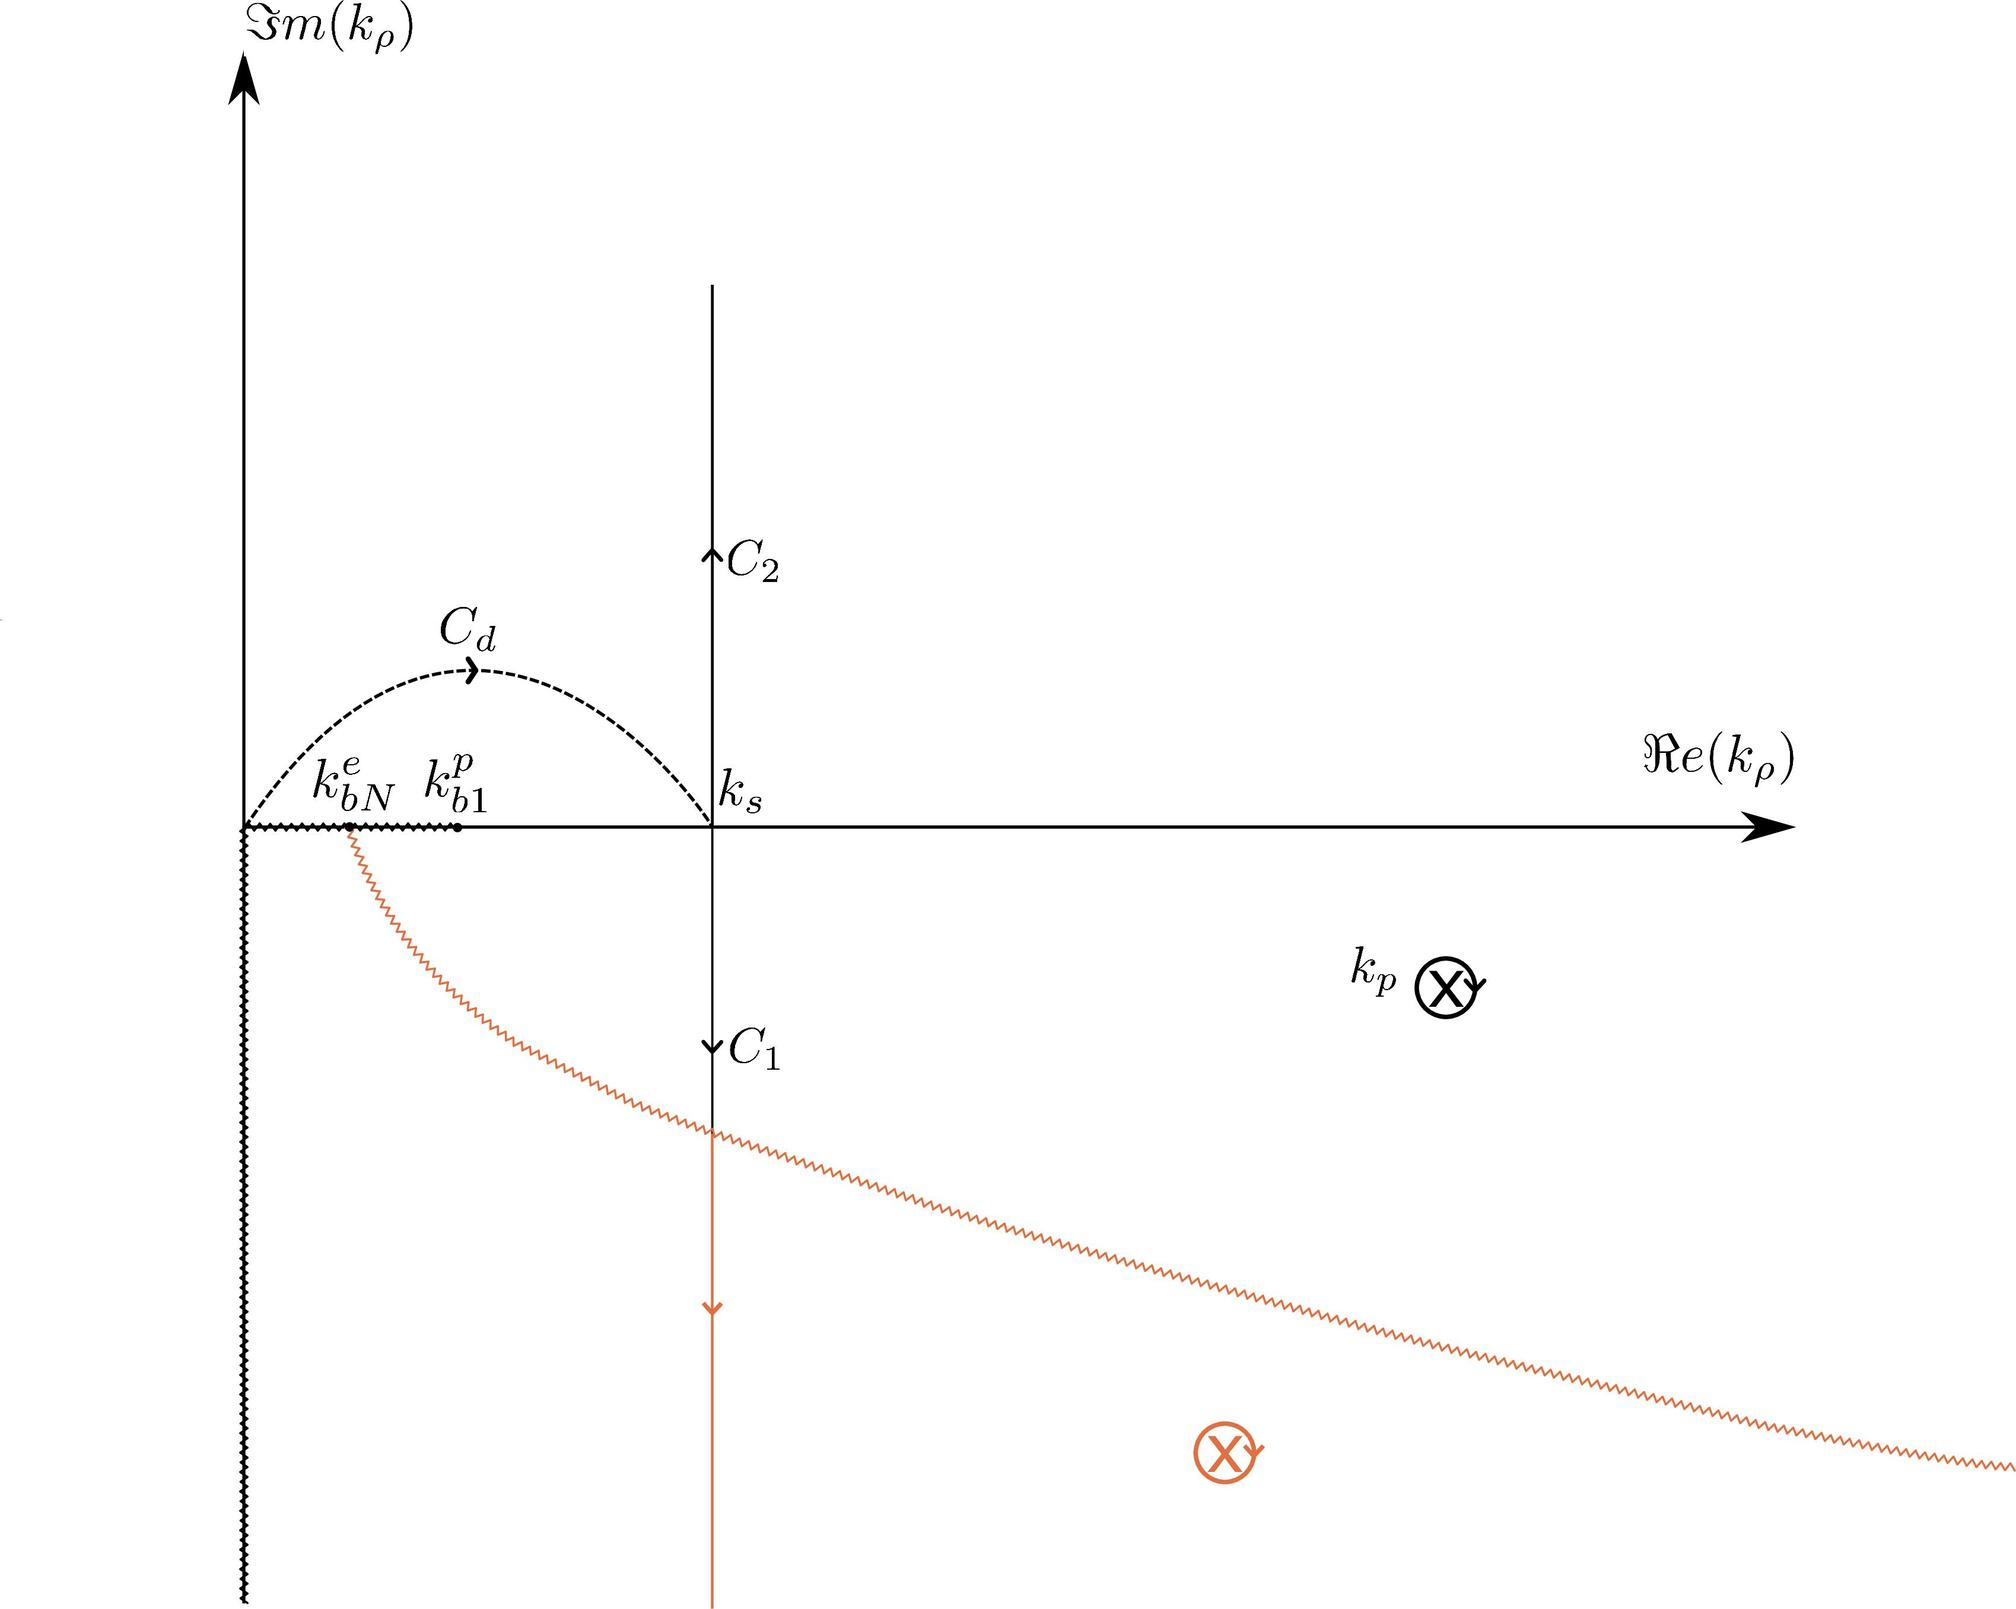What does the branch labeled \( C_d \) in the figure represent? A. A path showing the direction of decreasing real part of \( k_p \) B. A contour integral path in the complex \( k_p \) plane C. A branch cut for the complex function D. The trajectory of a particle in a field The branch labeled \( C_d \), depicted as a semicircular path in the figure, represents a contour integral path in the complex \( k_p \) plane. This specific form, in the shape of a semi-circle, is typically used in complex analysis for integrating around singular points or branch cuts safely. This path avoids direct interaction with the singular point at \( k_p \), which is marked by a cross on the real axis. In contrast, branch cuts and particle trajectories traditionally have different visual representations that include straight lines and varied paths, so options A, C, and D are incorrect. 